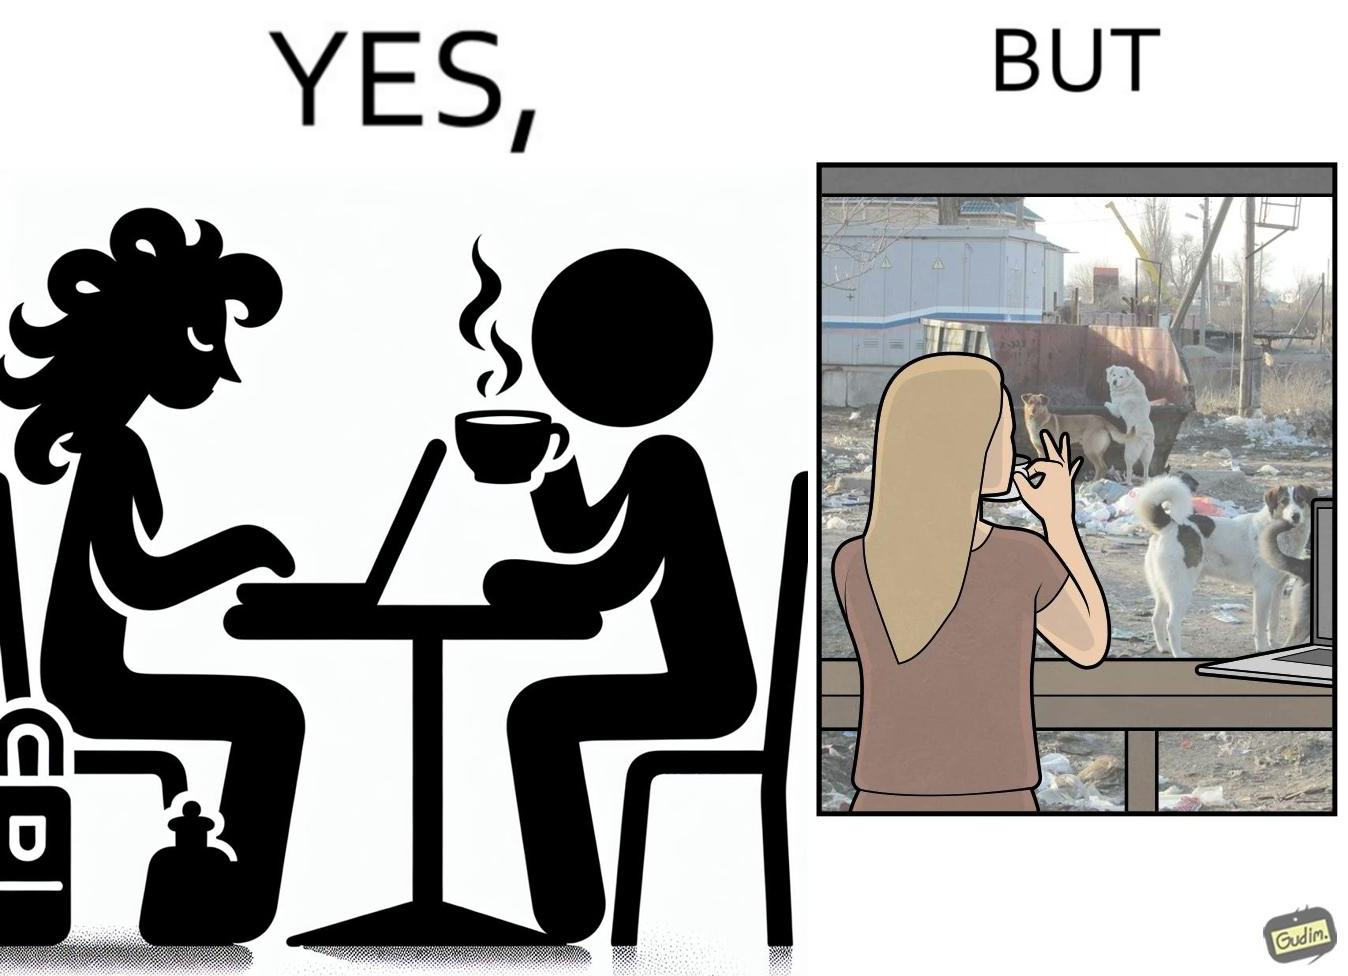What is shown in this image? The people nowadays are not concerned about the surroundings, everyone is busy in their life, like in the image it is shown that even when the woman notices the issues faced by stray but even then she is not ready to raise her voice or do some action for the cause 